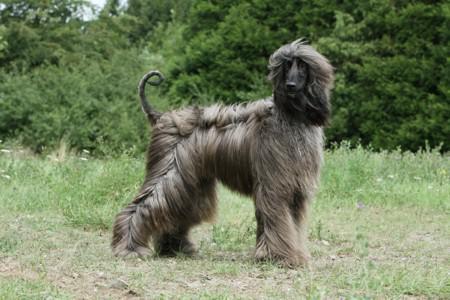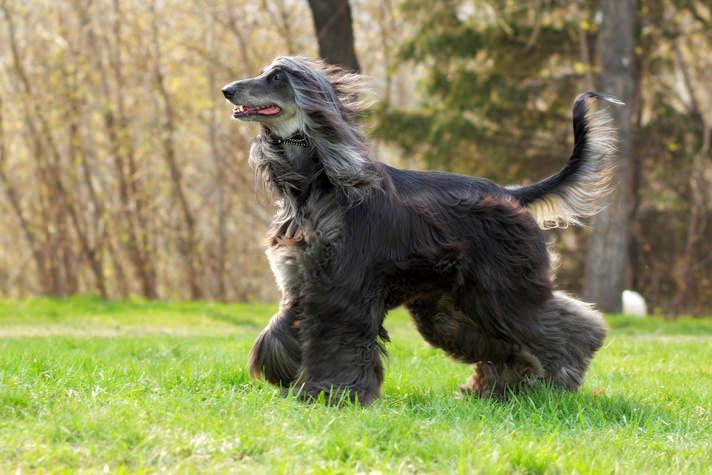The first image is the image on the left, the second image is the image on the right. For the images shown, is this caption "At least one image shows a dog bounding across the grass." true? Answer yes or no. No. 